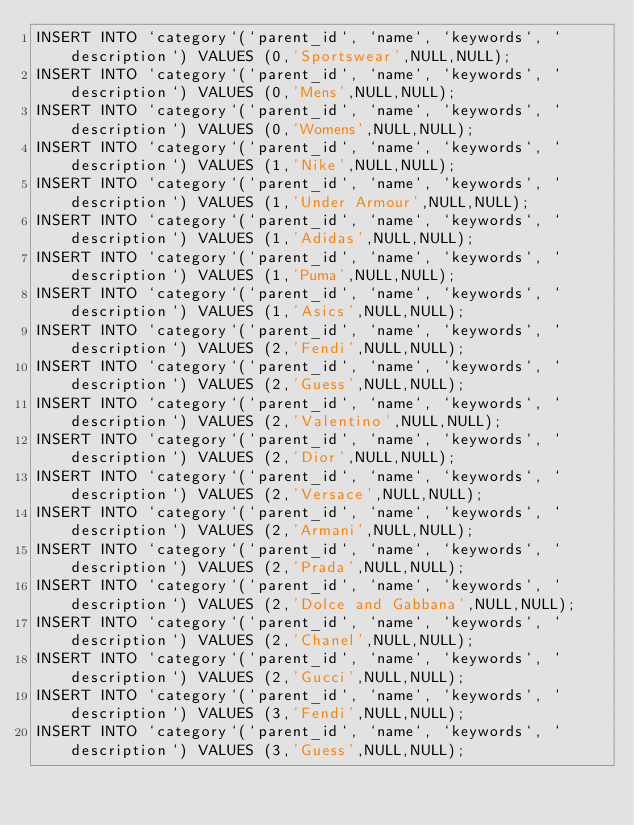Convert code to text. <code><loc_0><loc_0><loc_500><loc_500><_SQL_>INSERT INTO `category`(`parent_id`, `name`, `keywords`, `description`) VALUES (0,'Sportswear',NULL,NULL);
INSERT INTO `category`(`parent_id`, `name`, `keywords`, `description`) VALUES (0,'Mens',NULL,NULL);
INSERT INTO `category`(`parent_id`, `name`, `keywords`, `description`) VALUES (0,'Womens',NULL,NULL);
INSERT INTO `category`(`parent_id`, `name`, `keywords`, `description`) VALUES (1,'Nike',NULL,NULL);
INSERT INTO `category`(`parent_id`, `name`, `keywords`, `description`) VALUES (1,'Under Armour',NULL,NULL);
INSERT INTO `category`(`parent_id`, `name`, `keywords`, `description`) VALUES (1,'Adidas',NULL,NULL);
INSERT INTO `category`(`parent_id`, `name`, `keywords`, `description`) VALUES (1,'Puma',NULL,NULL);
INSERT INTO `category`(`parent_id`, `name`, `keywords`, `description`) VALUES (1,'Asics',NULL,NULL);
INSERT INTO `category`(`parent_id`, `name`, `keywords`, `description`) VALUES (2,'Fendi',NULL,NULL);
INSERT INTO `category`(`parent_id`, `name`, `keywords`, `description`) VALUES (2,'Guess',NULL,NULL);
INSERT INTO `category`(`parent_id`, `name`, `keywords`, `description`) VALUES (2,'Valentino',NULL,NULL);
INSERT INTO `category`(`parent_id`, `name`, `keywords`, `description`) VALUES (2,'Dior',NULL,NULL);
INSERT INTO `category`(`parent_id`, `name`, `keywords`, `description`) VALUES (2,'Versace',NULL,NULL);
INSERT INTO `category`(`parent_id`, `name`, `keywords`, `description`) VALUES (2,'Armani',NULL,NULL);
INSERT INTO `category`(`parent_id`, `name`, `keywords`, `description`) VALUES (2,'Prada',NULL,NULL);
INSERT INTO `category`(`parent_id`, `name`, `keywords`, `description`) VALUES (2,'Dolce and Gabbana',NULL,NULL);
INSERT INTO `category`(`parent_id`, `name`, `keywords`, `description`) VALUES (2,'Chanel',NULL,NULL);
INSERT INTO `category`(`parent_id`, `name`, `keywords`, `description`) VALUES (2,'Gucci',NULL,NULL);
INSERT INTO `category`(`parent_id`, `name`, `keywords`, `description`) VALUES (3,'Fendi',NULL,NULL);
INSERT INTO `category`(`parent_id`, `name`, `keywords`, `description`) VALUES (3,'Guess',NULL,NULL);</code> 